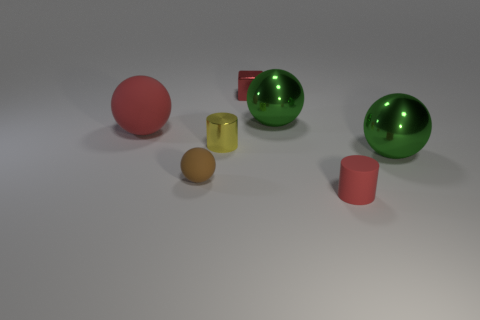Subtract all tiny spheres. How many spheres are left? 3 Subtract all purple cylinders. How many green spheres are left? 2 Add 2 small cyan metallic cylinders. How many objects exist? 9 Subtract 2 cylinders. How many cylinders are left? 0 Subtract all yellow cylinders. How many cylinders are left? 1 Add 2 brown rubber blocks. How many brown rubber blocks exist? 2 Subtract 0 gray blocks. How many objects are left? 7 Subtract all cylinders. How many objects are left? 5 Subtract all purple cylinders. Subtract all gray spheres. How many cylinders are left? 2 Subtract all big green shiny objects. Subtract all green metallic objects. How many objects are left? 3 